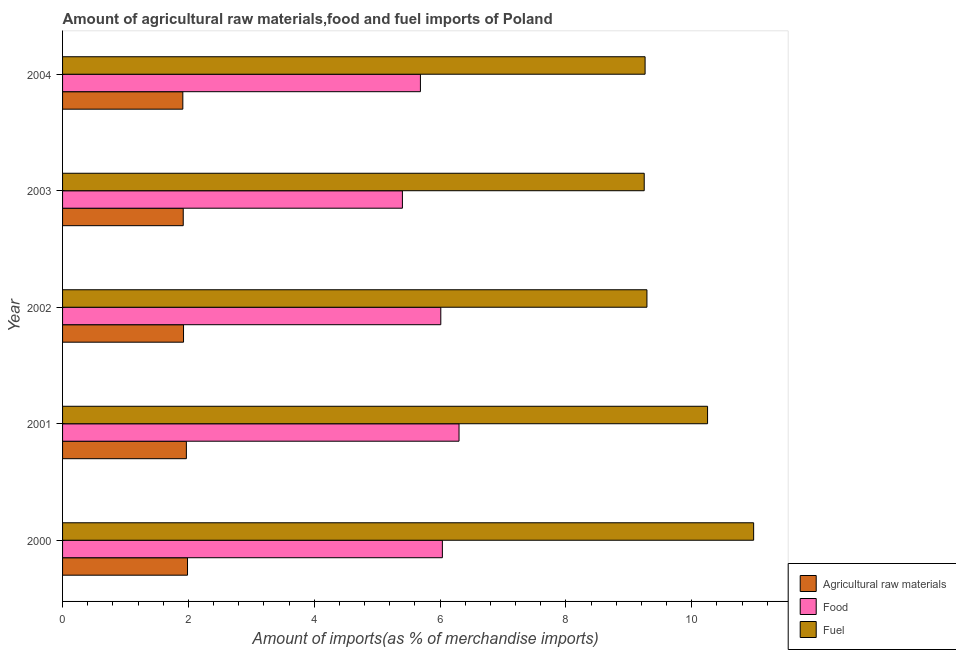How many groups of bars are there?
Provide a succinct answer. 5. Are the number of bars per tick equal to the number of legend labels?
Your answer should be very brief. Yes. How many bars are there on the 1st tick from the bottom?
Offer a terse response. 3. In how many cases, is the number of bars for a given year not equal to the number of legend labels?
Provide a succinct answer. 0. What is the percentage of fuel imports in 2002?
Give a very brief answer. 9.29. Across all years, what is the maximum percentage of food imports?
Ensure brevity in your answer.  6.3. Across all years, what is the minimum percentage of raw materials imports?
Ensure brevity in your answer.  1.91. What is the total percentage of raw materials imports in the graph?
Provide a succinct answer. 9.71. What is the difference between the percentage of food imports in 2000 and that in 2002?
Your answer should be very brief. 0.03. What is the difference between the percentage of fuel imports in 2002 and the percentage of food imports in 2001?
Your answer should be compact. 2.99. What is the average percentage of food imports per year?
Give a very brief answer. 5.89. In the year 2002, what is the difference between the percentage of food imports and percentage of fuel imports?
Offer a very short reply. -3.28. In how many years, is the percentage of fuel imports greater than 7.2 %?
Make the answer very short. 5. What is the ratio of the percentage of raw materials imports in 2000 to that in 2004?
Provide a succinct answer. 1.04. Is the percentage of fuel imports in 2000 less than that in 2004?
Provide a short and direct response. No. What is the difference between the highest and the second highest percentage of fuel imports?
Offer a terse response. 0.73. What is the difference between the highest and the lowest percentage of raw materials imports?
Provide a succinct answer. 0.07. In how many years, is the percentage of food imports greater than the average percentage of food imports taken over all years?
Provide a succinct answer. 3. What does the 3rd bar from the top in 2004 represents?
Make the answer very short. Agricultural raw materials. What does the 3rd bar from the bottom in 2000 represents?
Ensure brevity in your answer.  Fuel. Is it the case that in every year, the sum of the percentage of raw materials imports and percentage of food imports is greater than the percentage of fuel imports?
Your answer should be compact. No. Are the values on the major ticks of X-axis written in scientific E-notation?
Keep it short and to the point. No. Where does the legend appear in the graph?
Provide a succinct answer. Bottom right. How many legend labels are there?
Provide a short and direct response. 3. What is the title of the graph?
Keep it short and to the point. Amount of agricultural raw materials,food and fuel imports of Poland. Does "Machinery" appear as one of the legend labels in the graph?
Offer a terse response. No. What is the label or title of the X-axis?
Ensure brevity in your answer.  Amount of imports(as % of merchandise imports). What is the Amount of imports(as % of merchandise imports) of Agricultural raw materials in 2000?
Keep it short and to the point. 1.99. What is the Amount of imports(as % of merchandise imports) of Food in 2000?
Ensure brevity in your answer.  6.04. What is the Amount of imports(as % of merchandise imports) in Fuel in 2000?
Offer a terse response. 10.98. What is the Amount of imports(as % of merchandise imports) of Agricultural raw materials in 2001?
Your response must be concise. 1.97. What is the Amount of imports(as % of merchandise imports) of Food in 2001?
Ensure brevity in your answer.  6.3. What is the Amount of imports(as % of merchandise imports) of Fuel in 2001?
Ensure brevity in your answer.  10.25. What is the Amount of imports(as % of merchandise imports) of Agricultural raw materials in 2002?
Your answer should be compact. 1.92. What is the Amount of imports(as % of merchandise imports) in Food in 2002?
Your response must be concise. 6.01. What is the Amount of imports(as % of merchandise imports) in Fuel in 2002?
Keep it short and to the point. 9.29. What is the Amount of imports(as % of merchandise imports) of Agricultural raw materials in 2003?
Give a very brief answer. 1.92. What is the Amount of imports(as % of merchandise imports) of Food in 2003?
Your answer should be compact. 5.4. What is the Amount of imports(as % of merchandise imports) of Fuel in 2003?
Keep it short and to the point. 9.24. What is the Amount of imports(as % of merchandise imports) of Agricultural raw materials in 2004?
Offer a very short reply. 1.91. What is the Amount of imports(as % of merchandise imports) in Food in 2004?
Your answer should be compact. 5.69. What is the Amount of imports(as % of merchandise imports) in Fuel in 2004?
Provide a short and direct response. 9.26. Across all years, what is the maximum Amount of imports(as % of merchandise imports) in Agricultural raw materials?
Your response must be concise. 1.99. Across all years, what is the maximum Amount of imports(as % of merchandise imports) of Food?
Your answer should be compact. 6.3. Across all years, what is the maximum Amount of imports(as % of merchandise imports) of Fuel?
Your answer should be very brief. 10.98. Across all years, what is the minimum Amount of imports(as % of merchandise imports) in Agricultural raw materials?
Your answer should be very brief. 1.91. Across all years, what is the minimum Amount of imports(as % of merchandise imports) of Food?
Offer a very short reply. 5.4. Across all years, what is the minimum Amount of imports(as % of merchandise imports) in Fuel?
Ensure brevity in your answer.  9.24. What is the total Amount of imports(as % of merchandise imports) in Agricultural raw materials in the graph?
Make the answer very short. 9.71. What is the total Amount of imports(as % of merchandise imports) of Food in the graph?
Keep it short and to the point. 29.44. What is the total Amount of imports(as % of merchandise imports) of Fuel in the graph?
Your answer should be compact. 49.03. What is the difference between the Amount of imports(as % of merchandise imports) in Agricultural raw materials in 2000 and that in 2001?
Your response must be concise. 0.02. What is the difference between the Amount of imports(as % of merchandise imports) of Food in 2000 and that in 2001?
Make the answer very short. -0.26. What is the difference between the Amount of imports(as % of merchandise imports) in Fuel in 2000 and that in 2001?
Offer a very short reply. 0.73. What is the difference between the Amount of imports(as % of merchandise imports) in Agricultural raw materials in 2000 and that in 2002?
Offer a very short reply. 0.06. What is the difference between the Amount of imports(as % of merchandise imports) in Food in 2000 and that in 2002?
Offer a very short reply. 0.03. What is the difference between the Amount of imports(as % of merchandise imports) in Fuel in 2000 and that in 2002?
Provide a short and direct response. 1.7. What is the difference between the Amount of imports(as % of merchandise imports) in Agricultural raw materials in 2000 and that in 2003?
Provide a succinct answer. 0.07. What is the difference between the Amount of imports(as % of merchandise imports) of Food in 2000 and that in 2003?
Give a very brief answer. 0.64. What is the difference between the Amount of imports(as % of merchandise imports) in Fuel in 2000 and that in 2003?
Your answer should be very brief. 1.74. What is the difference between the Amount of imports(as % of merchandise imports) of Agricultural raw materials in 2000 and that in 2004?
Give a very brief answer. 0.07. What is the difference between the Amount of imports(as % of merchandise imports) of Food in 2000 and that in 2004?
Your answer should be very brief. 0.35. What is the difference between the Amount of imports(as % of merchandise imports) of Fuel in 2000 and that in 2004?
Your answer should be very brief. 1.73. What is the difference between the Amount of imports(as % of merchandise imports) of Agricultural raw materials in 2001 and that in 2002?
Make the answer very short. 0.05. What is the difference between the Amount of imports(as % of merchandise imports) of Food in 2001 and that in 2002?
Your answer should be very brief. 0.29. What is the difference between the Amount of imports(as % of merchandise imports) in Fuel in 2001 and that in 2002?
Your response must be concise. 0.96. What is the difference between the Amount of imports(as % of merchandise imports) in Agricultural raw materials in 2001 and that in 2003?
Make the answer very short. 0.05. What is the difference between the Amount of imports(as % of merchandise imports) in Food in 2001 and that in 2003?
Provide a short and direct response. 0.9. What is the difference between the Amount of imports(as % of merchandise imports) of Fuel in 2001 and that in 2003?
Your response must be concise. 1.01. What is the difference between the Amount of imports(as % of merchandise imports) in Agricultural raw materials in 2001 and that in 2004?
Give a very brief answer. 0.06. What is the difference between the Amount of imports(as % of merchandise imports) of Food in 2001 and that in 2004?
Provide a short and direct response. 0.61. What is the difference between the Amount of imports(as % of merchandise imports) of Fuel in 2001 and that in 2004?
Provide a succinct answer. 0.99. What is the difference between the Amount of imports(as % of merchandise imports) in Agricultural raw materials in 2002 and that in 2003?
Provide a succinct answer. 0. What is the difference between the Amount of imports(as % of merchandise imports) in Food in 2002 and that in 2003?
Keep it short and to the point. 0.61. What is the difference between the Amount of imports(as % of merchandise imports) in Fuel in 2002 and that in 2003?
Your answer should be compact. 0.04. What is the difference between the Amount of imports(as % of merchandise imports) in Agricultural raw materials in 2002 and that in 2004?
Offer a very short reply. 0.01. What is the difference between the Amount of imports(as % of merchandise imports) in Food in 2002 and that in 2004?
Keep it short and to the point. 0.32. What is the difference between the Amount of imports(as % of merchandise imports) of Fuel in 2002 and that in 2004?
Ensure brevity in your answer.  0.03. What is the difference between the Amount of imports(as % of merchandise imports) in Agricultural raw materials in 2003 and that in 2004?
Offer a terse response. 0.01. What is the difference between the Amount of imports(as % of merchandise imports) in Food in 2003 and that in 2004?
Provide a short and direct response. -0.29. What is the difference between the Amount of imports(as % of merchandise imports) of Fuel in 2003 and that in 2004?
Provide a succinct answer. -0.01. What is the difference between the Amount of imports(as % of merchandise imports) in Agricultural raw materials in 2000 and the Amount of imports(as % of merchandise imports) in Food in 2001?
Keep it short and to the point. -4.32. What is the difference between the Amount of imports(as % of merchandise imports) of Agricultural raw materials in 2000 and the Amount of imports(as % of merchandise imports) of Fuel in 2001?
Your answer should be compact. -8.27. What is the difference between the Amount of imports(as % of merchandise imports) in Food in 2000 and the Amount of imports(as % of merchandise imports) in Fuel in 2001?
Your answer should be very brief. -4.21. What is the difference between the Amount of imports(as % of merchandise imports) in Agricultural raw materials in 2000 and the Amount of imports(as % of merchandise imports) in Food in 2002?
Keep it short and to the point. -4.03. What is the difference between the Amount of imports(as % of merchandise imports) of Agricultural raw materials in 2000 and the Amount of imports(as % of merchandise imports) of Fuel in 2002?
Your answer should be compact. -7.3. What is the difference between the Amount of imports(as % of merchandise imports) in Food in 2000 and the Amount of imports(as % of merchandise imports) in Fuel in 2002?
Offer a very short reply. -3.25. What is the difference between the Amount of imports(as % of merchandise imports) in Agricultural raw materials in 2000 and the Amount of imports(as % of merchandise imports) in Food in 2003?
Your response must be concise. -3.42. What is the difference between the Amount of imports(as % of merchandise imports) of Agricultural raw materials in 2000 and the Amount of imports(as % of merchandise imports) of Fuel in 2003?
Keep it short and to the point. -7.26. What is the difference between the Amount of imports(as % of merchandise imports) in Food in 2000 and the Amount of imports(as % of merchandise imports) in Fuel in 2003?
Provide a succinct answer. -3.21. What is the difference between the Amount of imports(as % of merchandise imports) of Agricultural raw materials in 2000 and the Amount of imports(as % of merchandise imports) of Food in 2004?
Your answer should be very brief. -3.7. What is the difference between the Amount of imports(as % of merchandise imports) of Agricultural raw materials in 2000 and the Amount of imports(as % of merchandise imports) of Fuel in 2004?
Give a very brief answer. -7.27. What is the difference between the Amount of imports(as % of merchandise imports) of Food in 2000 and the Amount of imports(as % of merchandise imports) of Fuel in 2004?
Offer a very short reply. -3.22. What is the difference between the Amount of imports(as % of merchandise imports) in Agricultural raw materials in 2001 and the Amount of imports(as % of merchandise imports) in Food in 2002?
Make the answer very short. -4.04. What is the difference between the Amount of imports(as % of merchandise imports) of Agricultural raw materials in 2001 and the Amount of imports(as % of merchandise imports) of Fuel in 2002?
Offer a very short reply. -7.32. What is the difference between the Amount of imports(as % of merchandise imports) in Food in 2001 and the Amount of imports(as % of merchandise imports) in Fuel in 2002?
Your answer should be very brief. -2.99. What is the difference between the Amount of imports(as % of merchandise imports) of Agricultural raw materials in 2001 and the Amount of imports(as % of merchandise imports) of Food in 2003?
Give a very brief answer. -3.43. What is the difference between the Amount of imports(as % of merchandise imports) of Agricultural raw materials in 2001 and the Amount of imports(as % of merchandise imports) of Fuel in 2003?
Provide a short and direct response. -7.28. What is the difference between the Amount of imports(as % of merchandise imports) in Food in 2001 and the Amount of imports(as % of merchandise imports) in Fuel in 2003?
Provide a succinct answer. -2.94. What is the difference between the Amount of imports(as % of merchandise imports) of Agricultural raw materials in 2001 and the Amount of imports(as % of merchandise imports) of Food in 2004?
Ensure brevity in your answer.  -3.72. What is the difference between the Amount of imports(as % of merchandise imports) in Agricultural raw materials in 2001 and the Amount of imports(as % of merchandise imports) in Fuel in 2004?
Your response must be concise. -7.29. What is the difference between the Amount of imports(as % of merchandise imports) of Food in 2001 and the Amount of imports(as % of merchandise imports) of Fuel in 2004?
Keep it short and to the point. -2.96. What is the difference between the Amount of imports(as % of merchandise imports) in Agricultural raw materials in 2002 and the Amount of imports(as % of merchandise imports) in Food in 2003?
Provide a short and direct response. -3.48. What is the difference between the Amount of imports(as % of merchandise imports) of Agricultural raw materials in 2002 and the Amount of imports(as % of merchandise imports) of Fuel in 2003?
Provide a short and direct response. -7.32. What is the difference between the Amount of imports(as % of merchandise imports) in Food in 2002 and the Amount of imports(as % of merchandise imports) in Fuel in 2003?
Provide a short and direct response. -3.23. What is the difference between the Amount of imports(as % of merchandise imports) in Agricultural raw materials in 2002 and the Amount of imports(as % of merchandise imports) in Food in 2004?
Keep it short and to the point. -3.76. What is the difference between the Amount of imports(as % of merchandise imports) in Agricultural raw materials in 2002 and the Amount of imports(as % of merchandise imports) in Fuel in 2004?
Provide a succinct answer. -7.34. What is the difference between the Amount of imports(as % of merchandise imports) in Food in 2002 and the Amount of imports(as % of merchandise imports) in Fuel in 2004?
Ensure brevity in your answer.  -3.25. What is the difference between the Amount of imports(as % of merchandise imports) in Agricultural raw materials in 2003 and the Amount of imports(as % of merchandise imports) in Food in 2004?
Your response must be concise. -3.77. What is the difference between the Amount of imports(as % of merchandise imports) in Agricultural raw materials in 2003 and the Amount of imports(as % of merchandise imports) in Fuel in 2004?
Make the answer very short. -7.34. What is the difference between the Amount of imports(as % of merchandise imports) of Food in 2003 and the Amount of imports(as % of merchandise imports) of Fuel in 2004?
Your answer should be compact. -3.86. What is the average Amount of imports(as % of merchandise imports) in Agricultural raw materials per year?
Offer a terse response. 1.94. What is the average Amount of imports(as % of merchandise imports) of Food per year?
Offer a very short reply. 5.89. What is the average Amount of imports(as % of merchandise imports) in Fuel per year?
Your answer should be very brief. 9.81. In the year 2000, what is the difference between the Amount of imports(as % of merchandise imports) of Agricultural raw materials and Amount of imports(as % of merchandise imports) of Food?
Offer a very short reply. -4.05. In the year 2000, what is the difference between the Amount of imports(as % of merchandise imports) in Agricultural raw materials and Amount of imports(as % of merchandise imports) in Fuel?
Ensure brevity in your answer.  -9. In the year 2000, what is the difference between the Amount of imports(as % of merchandise imports) in Food and Amount of imports(as % of merchandise imports) in Fuel?
Your answer should be very brief. -4.95. In the year 2001, what is the difference between the Amount of imports(as % of merchandise imports) of Agricultural raw materials and Amount of imports(as % of merchandise imports) of Food?
Give a very brief answer. -4.33. In the year 2001, what is the difference between the Amount of imports(as % of merchandise imports) of Agricultural raw materials and Amount of imports(as % of merchandise imports) of Fuel?
Provide a succinct answer. -8.28. In the year 2001, what is the difference between the Amount of imports(as % of merchandise imports) in Food and Amount of imports(as % of merchandise imports) in Fuel?
Provide a short and direct response. -3.95. In the year 2002, what is the difference between the Amount of imports(as % of merchandise imports) of Agricultural raw materials and Amount of imports(as % of merchandise imports) of Food?
Keep it short and to the point. -4.09. In the year 2002, what is the difference between the Amount of imports(as % of merchandise imports) in Agricultural raw materials and Amount of imports(as % of merchandise imports) in Fuel?
Offer a terse response. -7.37. In the year 2002, what is the difference between the Amount of imports(as % of merchandise imports) in Food and Amount of imports(as % of merchandise imports) in Fuel?
Offer a very short reply. -3.28. In the year 2003, what is the difference between the Amount of imports(as % of merchandise imports) in Agricultural raw materials and Amount of imports(as % of merchandise imports) in Food?
Make the answer very short. -3.48. In the year 2003, what is the difference between the Amount of imports(as % of merchandise imports) in Agricultural raw materials and Amount of imports(as % of merchandise imports) in Fuel?
Provide a short and direct response. -7.33. In the year 2003, what is the difference between the Amount of imports(as % of merchandise imports) of Food and Amount of imports(as % of merchandise imports) of Fuel?
Keep it short and to the point. -3.84. In the year 2004, what is the difference between the Amount of imports(as % of merchandise imports) in Agricultural raw materials and Amount of imports(as % of merchandise imports) in Food?
Provide a short and direct response. -3.78. In the year 2004, what is the difference between the Amount of imports(as % of merchandise imports) in Agricultural raw materials and Amount of imports(as % of merchandise imports) in Fuel?
Your answer should be very brief. -7.35. In the year 2004, what is the difference between the Amount of imports(as % of merchandise imports) in Food and Amount of imports(as % of merchandise imports) in Fuel?
Ensure brevity in your answer.  -3.57. What is the ratio of the Amount of imports(as % of merchandise imports) in Agricultural raw materials in 2000 to that in 2001?
Your response must be concise. 1.01. What is the ratio of the Amount of imports(as % of merchandise imports) in Food in 2000 to that in 2001?
Offer a terse response. 0.96. What is the ratio of the Amount of imports(as % of merchandise imports) in Fuel in 2000 to that in 2001?
Provide a short and direct response. 1.07. What is the ratio of the Amount of imports(as % of merchandise imports) in Agricultural raw materials in 2000 to that in 2002?
Keep it short and to the point. 1.03. What is the ratio of the Amount of imports(as % of merchandise imports) of Food in 2000 to that in 2002?
Your answer should be very brief. 1. What is the ratio of the Amount of imports(as % of merchandise imports) in Fuel in 2000 to that in 2002?
Provide a succinct answer. 1.18. What is the ratio of the Amount of imports(as % of merchandise imports) of Agricultural raw materials in 2000 to that in 2003?
Keep it short and to the point. 1.04. What is the ratio of the Amount of imports(as % of merchandise imports) of Food in 2000 to that in 2003?
Keep it short and to the point. 1.12. What is the ratio of the Amount of imports(as % of merchandise imports) of Fuel in 2000 to that in 2003?
Provide a short and direct response. 1.19. What is the ratio of the Amount of imports(as % of merchandise imports) of Agricultural raw materials in 2000 to that in 2004?
Your response must be concise. 1.04. What is the ratio of the Amount of imports(as % of merchandise imports) in Food in 2000 to that in 2004?
Make the answer very short. 1.06. What is the ratio of the Amount of imports(as % of merchandise imports) of Fuel in 2000 to that in 2004?
Your answer should be compact. 1.19. What is the ratio of the Amount of imports(as % of merchandise imports) of Agricultural raw materials in 2001 to that in 2002?
Your answer should be very brief. 1.02. What is the ratio of the Amount of imports(as % of merchandise imports) of Food in 2001 to that in 2002?
Offer a very short reply. 1.05. What is the ratio of the Amount of imports(as % of merchandise imports) in Fuel in 2001 to that in 2002?
Your answer should be compact. 1.1. What is the ratio of the Amount of imports(as % of merchandise imports) in Food in 2001 to that in 2003?
Provide a short and direct response. 1.17. What is the ratio of the Amount of imports(as % of merchandise imports) of Fuel in 2001 to that in 2003?
Make the answer very short. 1.11. What is the ratio of the Amount of imports(as % of merchandise imports) of Agricultural raw materials in 2001 to that in 2004?
Your response must be concise. 1.03. What is the ratio of the Amount of imports(as % of merchandise imports) in Food in 2001 to that in 2004?
Your answer should be very brief. 1.11. What is the ratio of the Amount of imports(as % of merchandise imports) of Fuel in 2001 to that in 2004?
Offer a terse response. 1.11. What is the ratio of the Amount of imports(as % of merchandise imports) of Food in 2002 to that in 2003?
Offer a terse response. 1.11. What is the ratio of the Amount of imports(as % of merchandise imports) in Agricultural raw materials in 2002 to that in 2004?
Offer a terse response. 1.01. What is the ratio of the Amount of imports(as % of merchandise imports) of Food in 2002 to that in 2004?
Provide a succinct answer. 1.06. What is the ratio of the Amount of imports(as % of merchandise imports) in Fuel in 2002 to that in 2004?
Provide a short and direct response. 1. What is the ratio of the Amount of imports(as % of merchandise imports) in Food in 2003 to that in 2004?
Your answer should be very brief. 0.95. What is the difference between the highest and the second highest Amount of imports(as % of merchandise imports) of Agricultural raw materials?
Provide a short and direct response. 0.02. What is the difference between the highest and the second highest Amount of imports(as % of merchandise imports) in Food?
Your answer should be compact. 0.26. What is the difference between the highest and the second highest Amount of imports(as % of merchandise imports) in Fuel?
Your answer should be very brief. 0.73. What is the difference between the highest and the lowest Amount of imports(as % of merchandise imports) of Agricultural raw materials?
Provide a succinct answer. 0.07. What is the difference between the highest and the lowest Amount of imports(as % of merchandise imports) of Food?
Make the answer very short. 0.9. What is the difference between the highest and the lowest Amount of imports(as % of merchandise imports) of Fuel?
Your answer should be very brief. 1.74. 